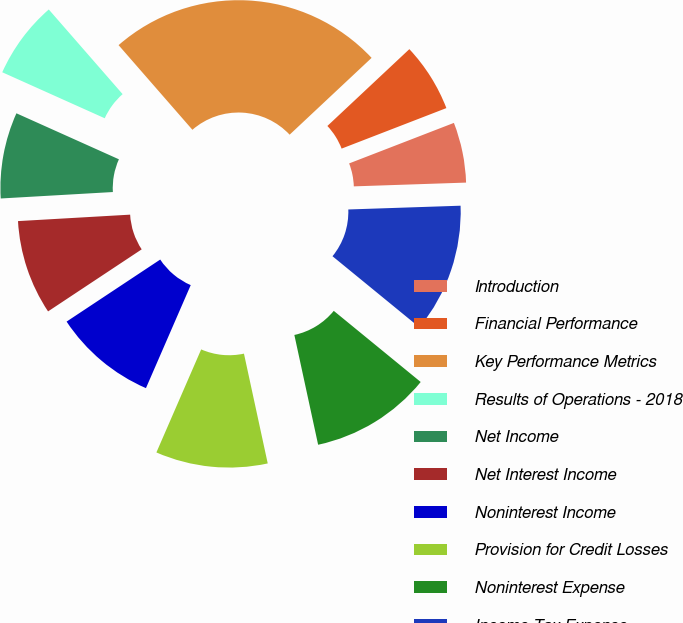<chart> <loc_0><loc_0><loc_500><loc_500><pie_chart><fcel>Introduction<fcel>Financial Performance<fcel>Key Performance Metrics<fcel>Results of Operations - 2018<fcel>Net Income<fcel>Net Interest Income<fcel>Noninterest Income<fcel>Provision for Credit Losses<fcel>Noninterest Expense<fcel>Income Tax Expense<nl><fcel>5.34%<fcel>6.11%<fcel>24.43%<fcel>6.87%<fcel>7.63%<fcel>8.4%<fcel>9.16%<fcel>9.92%<fcel>10.69%<fcel>11.45%<nl></chart> 